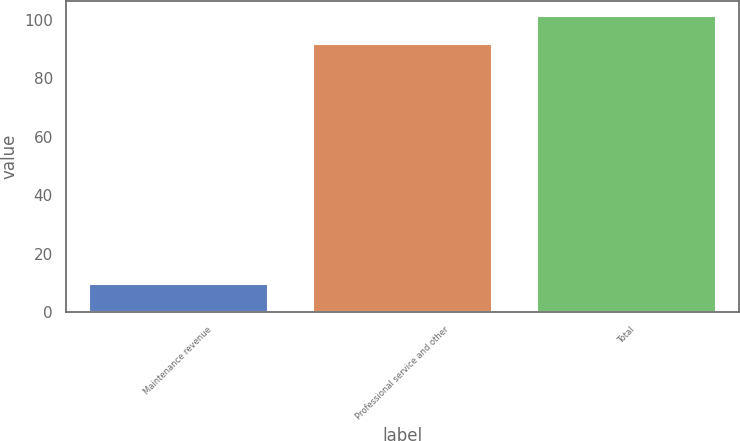Convert chart to OTSL. <chart><loc_0><loc_0><loc_500><loc_500><bar_chart><fcel>Maintenance revenue<fcel>Professional service and other<fcel>Total<nl><fcel>9.7<fcel>91.7<fcel>101.4<nl></chart> 